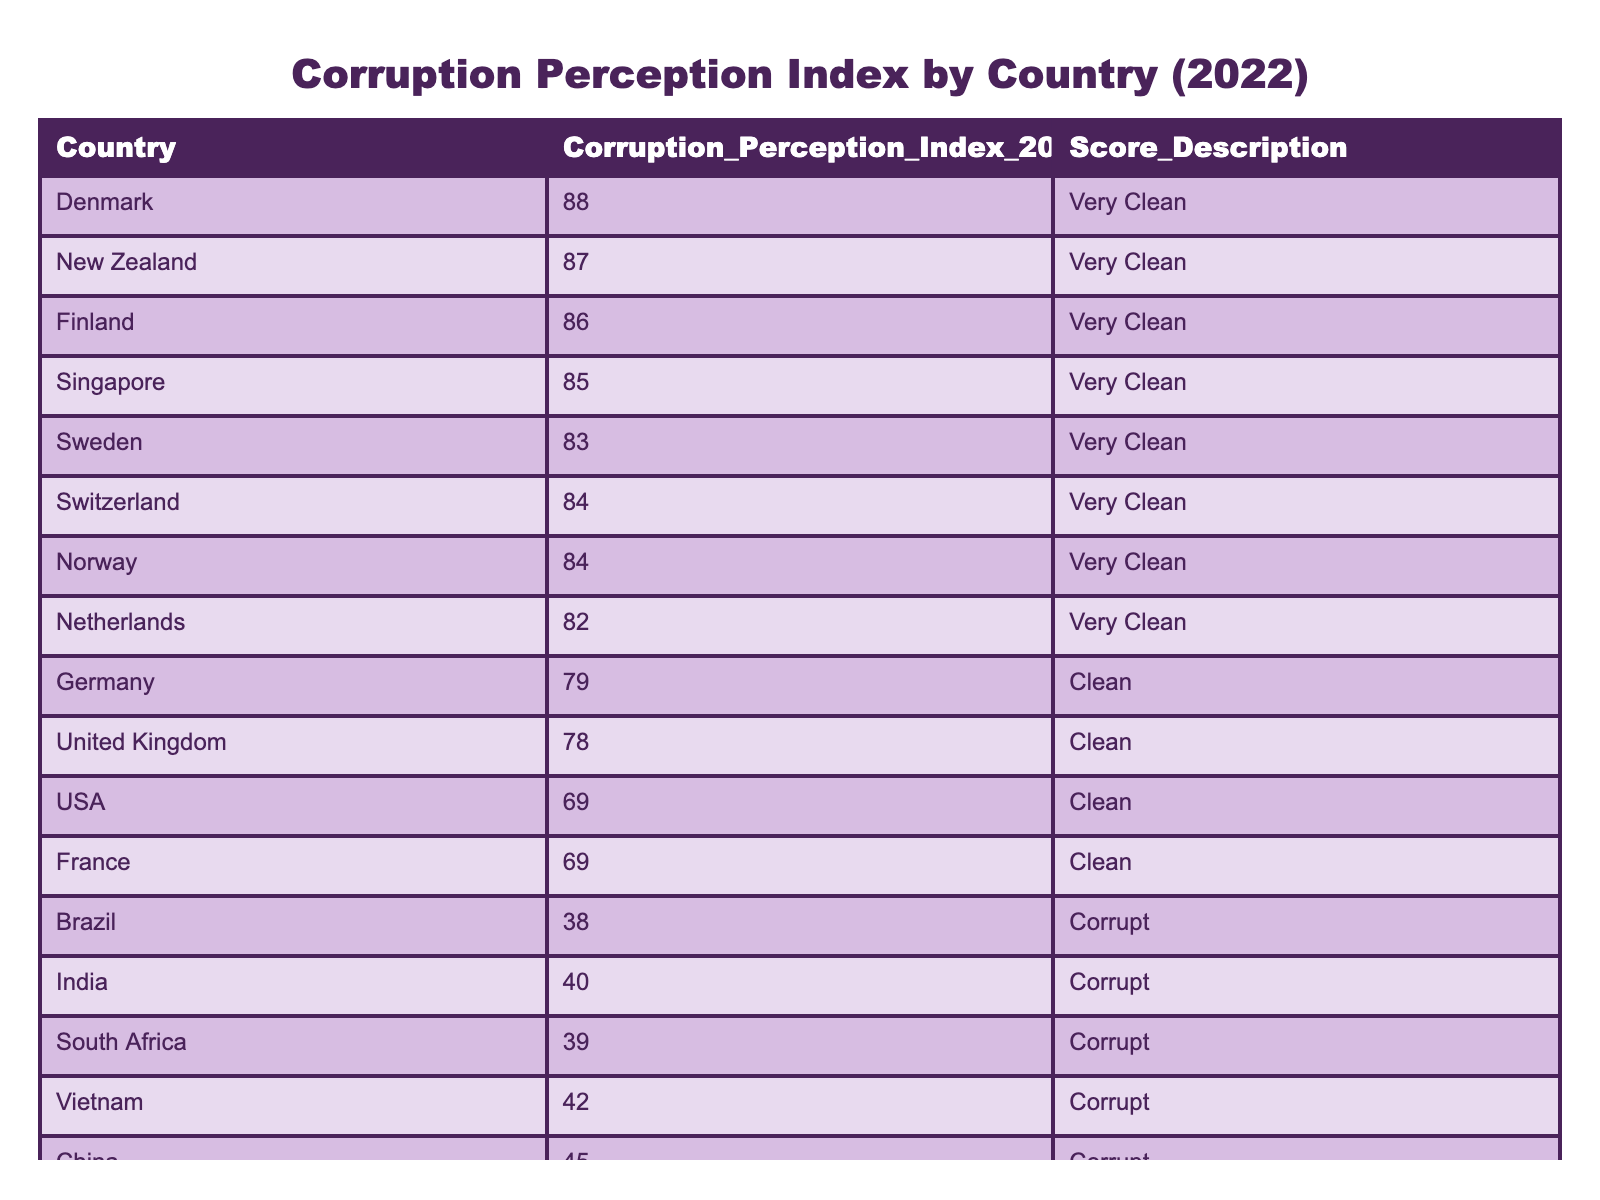What is the Corruption Perception Index score for Vietnam in 2022? The table shows that Vietnam has a Corruption Perception Index score of 42 in 2022.
Answer: 42 Which country has the highest score in the table? According to the table, Denmark has the highest score of 88.
Answer: Denmark How many countries scored above 80 in the Corruption Perception Index in 2022? The countries that scored above 80 are Denmark (88), New Zealand (87), Finland (86), Singapore (85), Sweden (83), Switzerland (84), and Norway (84). There are 7 countries.
Answer: 7 Is the Corruption Perception Index score of the USA considered "Clean"? The score for the USA is 69, which is described as "Clean" in the table. Therefore, the statement is true.
Answer: Yes What is the average Corruption Perception Index score for the countries considered "Corrupt"? The scores for the countries labeled as "Corrupt" are Brazil (38), India (40), South Africa (39), Vietnam (42), and China (45). The total is 204, and there are 5 countries, so the average is 204/5 = 40.8.
Answer: 40.8 Which country has a score that is closest to the median score of all listed countries? To find the median, we first list the scores in order: 12, 13, 24, 33, 38, 39, 40, 42, 45, 69, 69, 68, 78, 79, 82, 83, 84, 84, 85, 86, 87, 88. The median score (middle value) is 68, and that score corresponds to the USA.
Answer: USA Are there more countries classified as "Very Corrupt" or "Corrupt"? The table lists 5 countries as "Very Corrupt" (Russia, Nigeria, Somalia, Syria) and 5 countries as "Corrupt" (Brazil, India, South Africa, Vietnam, China). Therefore, the amount is equal.
Answer: Equal Which country has the lowest score and how is it classified? According to the table, Somalia has the lowest score of 12, and it is classified as "Very Corrupt".
Answer: Somalia, Very Corrupt 